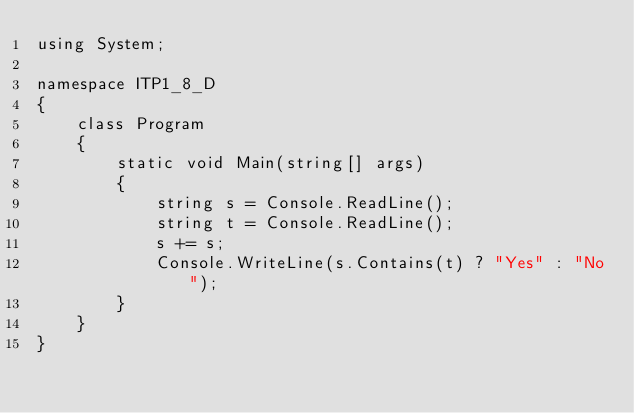Convert code to text. <code><loc_0><loc_0><loc_500><loc_500><_C#_>using System;

namespace ITP1_8_D
{
    class Program
    {
        static void Main(string[] args)
        {
            string s = Console.ReadLine();
            string t = Console.ReadLine();
            s += s;
            Console.WriteLine(s.Contains(t) ? "Yes" : "No");
        }
    }
}</code> 